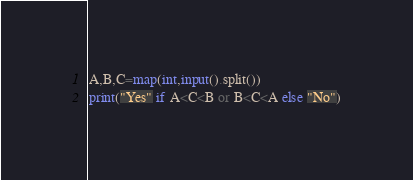Convert code to text. <code><loc_0><loc_0><loc_500><loc_500><_Python_>A,B,C=map(int,input().split())
print("Yes" if A<C<B or B<C<A else "No")</code> 